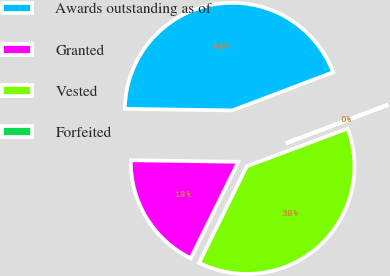Convert chart to OTSL. <chart><loc_0><loc_0><loc_500><loc_500><pie_chart><fcel>Awards outstanding as of<fcel>Granted<fcel>Vested<fcel>Forfeited<nl><fcel>44.0%<fcel>17.93%<fcel>38.0%<fcel>0.07%<nl></chart> 